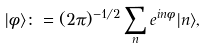Convert formula to latex. <formula><loc_0><loc_0><loc_500><loc_500>| \phi \rangle \colon = ( 2 \pi ) ^ { - 1 / 2 } \sum _ { n } e ^ { i n \phi } | n \rangle ,</formula> 